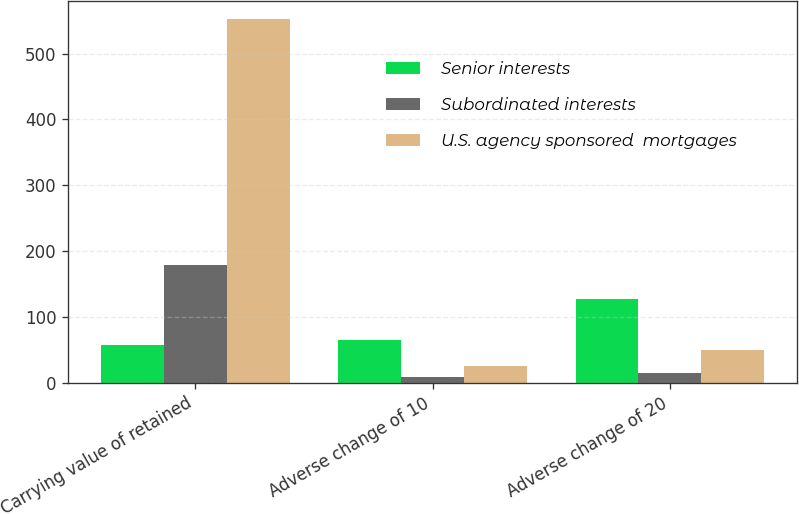Convert chart to OTSL. <chart><loc_0><loc_0><loc_500><loc_500><stacked_bar_chart><ecel><fcel>Carrying value of retained<fcel>Adverse change of 10<fcel>Adverse change of 20<nl><fcel>Senior interests<fcel>57<fcel>65<fcel>127<nl><fcel>Subordinated interests<fcel>179<fcel>8<fcel>15<nl><fcel>U.S. agency sponsored  mortgages<fcel>553<fcel>25<fcel>49<nl></chart> 